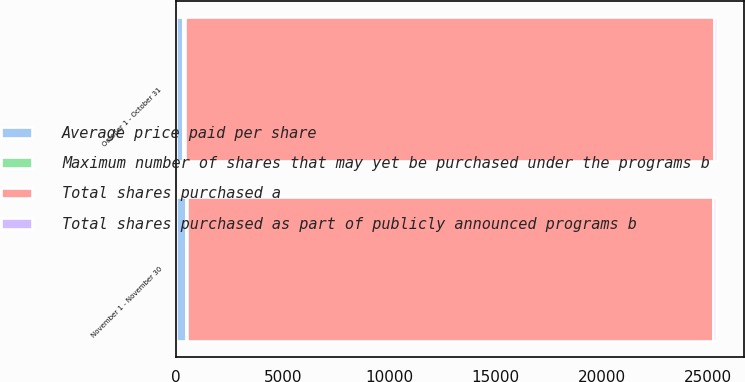Convert chart. <chart><loc_0><loc_0><loc_500><loc_500><stacked_bar_chart><ecel><fcel>October 1 - October 31<fcel>November 1 - November 30<nl><fcel>Average price paid per share<fcel>318<fcel>433<nl><fcel>Maximum number of shares that may yet be purchased under the programs b<fcel>70.86<fcel>70.48<nl><fcel>Total shares purchased as part of publicly announced programs b<fcel>145<fcel>145<nl><fcel>Total shares purchased a<fcel>24855<fcel>24710<nl></chart> 